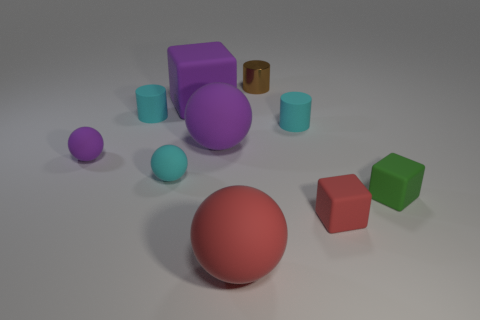Is there anything else that is made of the same material as the brown cylinder?
Offer a very short reply. No. What color is the small cylinder that is right of the tiny cyan ball and in front of the tiny metal cylinder?
Your answer should be compact. Cyan. Is the size of the purple matte ball behind the tiny purple matte sphere the same as the block that is behind the tiny purple rubber ball?
Your answer should be very brief. Yes. What number of other objects are there of the same size as the purple rubber block?
Make the answer very short. 2. There is a ball in front of the small red rubber object; what number of big purple rubber balls are in front of it?
Offer a terse response. 0. Is the number of tiny cyan rubber cylinders to the right of the green cube less than the number of cyan spheres?
Provide a short and direct response. Yes. There is a big purple object in front of the small cyan rubber cylinder behind the tiny matte cylinder to the right of the tiny brown cylinder; what is its shape?
Offer a very short reply. Sphere. Do the metal object and the large red thing have the same shape?
Give a very brief answer. No. What number of other objects are there of the same shape as the small red object?
Ensure brevity in your answer.  2. There is a shiny object that is the same size as the green matte thing; what color is it?
Offer a very short reply. Brown. 